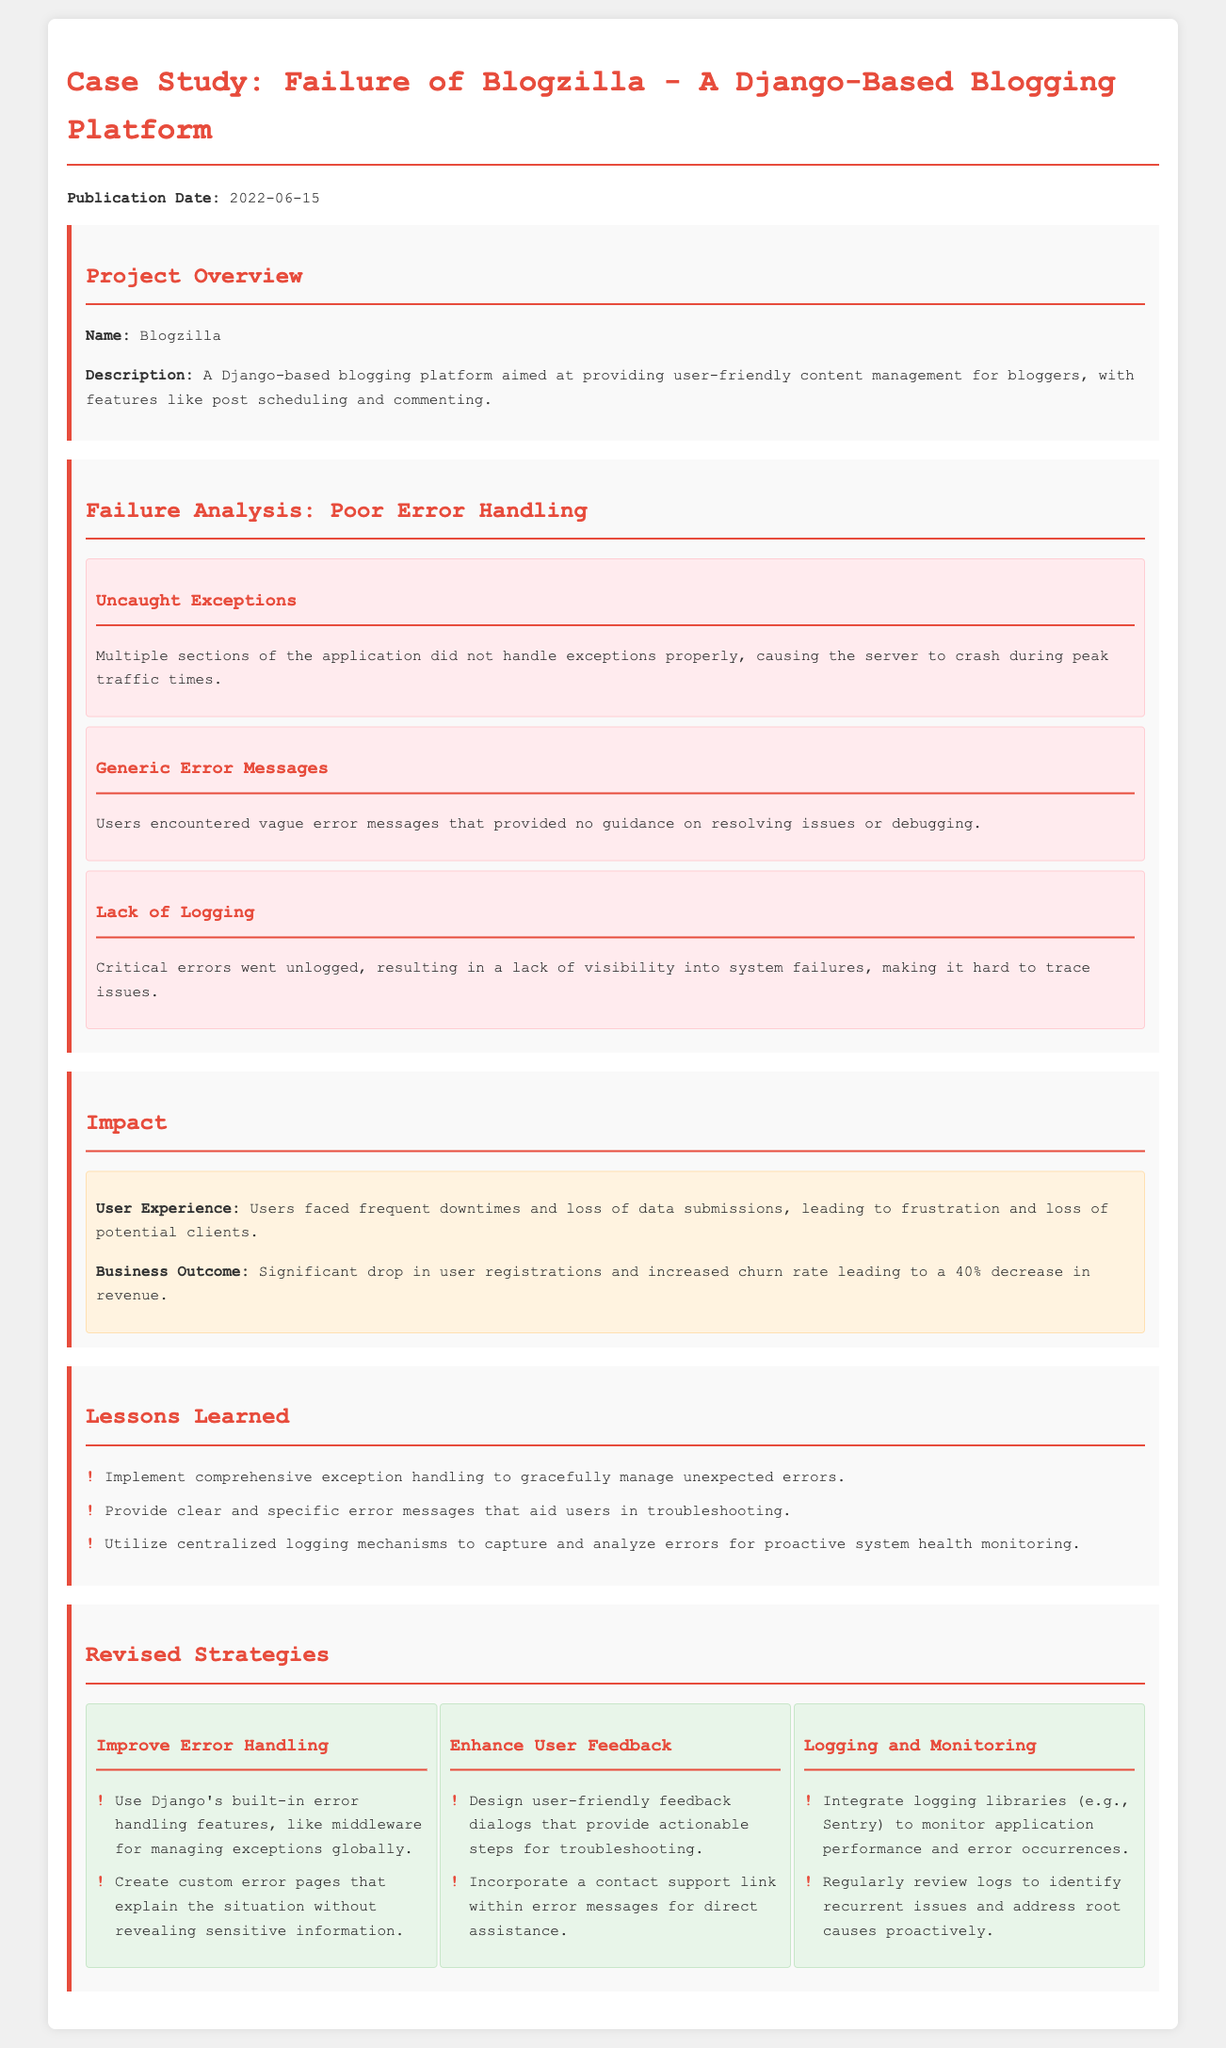What is the publication date? The document states the publication date of the case study as June 15, 2022.
Answer: June 15, 2022 What is the main issue identified in the failure analysis? The document highlights poor error handling as the main issue causing the project's failure.
Answer: Poor error handling How many strategies are proposed for revised error handling? The document lists three strategies for improving error handling in the project.
Answer: Three What was the percentage decrease in revenue? The impact section specifies a 40% decrease in revenue as a consequence of the project's failures.
Answer: 40% Which logging library is suggested for monitoring? The revised strategies recommend integrating Sentry as a logging library.
Answer: Sentry What user experience issue was identified? The document notes that users faced frequent downtimes, leading to frustration.
Answer: Frequent downtimes What specific type of error was mentioned regarding user messages? The analysis points out generic error messages that provided no guidance to users.
Answer: Generic error messages What feature aimed at enhancing user feedback is suggested? Creating user-friendly feedback dialogs that provide actionable steps is recommended.
Answer: Feedback dialogs 